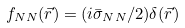Convert formula to latex. <formula><loc_0><loc_0><loc_500><loc_500>f _ { N N } ( \vec { r } ) = ( i \bar { \sigma } _ { N N } / 2 ) \delta ( \vec { r } )</formula> 